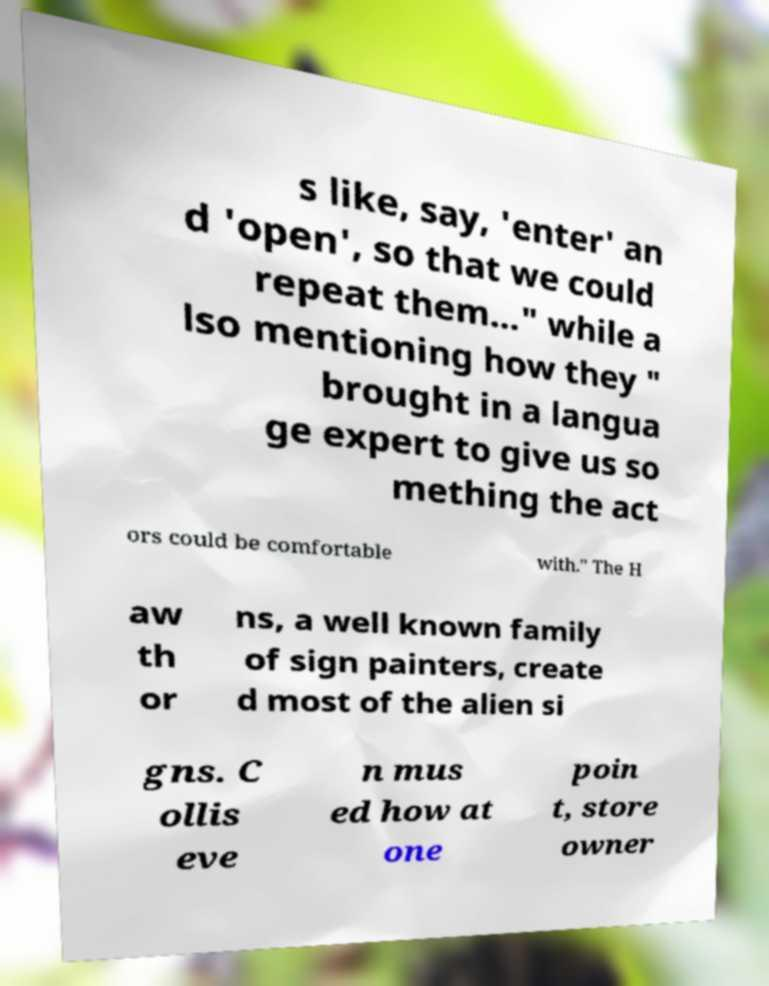What messages or text are displayed in this image? I need them in a readable, typed format. s like, say, 'enter' an d 'open', so that we could repeat them..." while a lso mentioning how they " brought in a langua ge expert to give us so mething the act ors could be comfortable with." The H aw th or ns, a well known family of sign painters, create d most of the alien si gns. C ollis eve n mus ed how at one poin t, store owner 